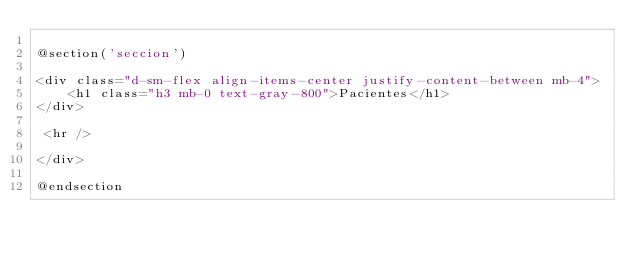Convert code to text. <code><loc_0><loc_0><loc_500><loc_500><_PHP_>
@section('seccion')

<div class="d-sm-flex align-items-center justify-content-between mb-4">
    <h1 class="h3 mb-0 text-gray-800">Pacientes</h1>
</div>

 <hr />

</div>

@endsection</code> 